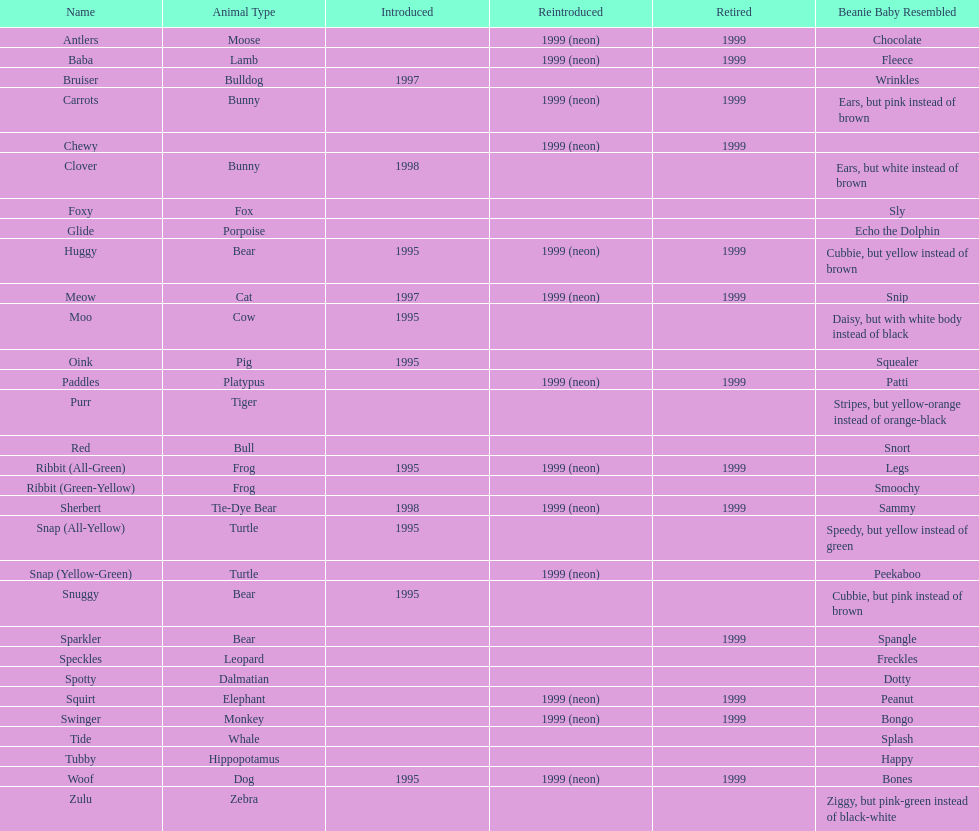What is the name of the last pillow pal on this chart? Zulu. 